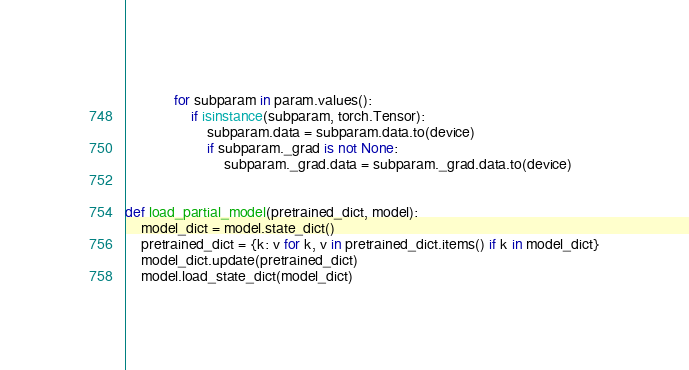Convert code to text. <code><loc_0><loc_0><loc_500><loc_500><_Python_>            for subparam in param.values():
                if isinstance(subparam, torch.Tensor):
                    subparam.data = subparam.data.to(device)
                    if subparam._grad is not None:
                        subparam._grad.data = subparam._grad.data.to(device)


def load_partial_model(pretrained_dict, model):
    model_dict = model.state_dict()
    pretrained_dict = {k: v for k, v in pretrained_dict.items() if k in model_dict}
    model_dict.update(pretrained_dict)
    model.load_state_dict(model_dict)</code> 